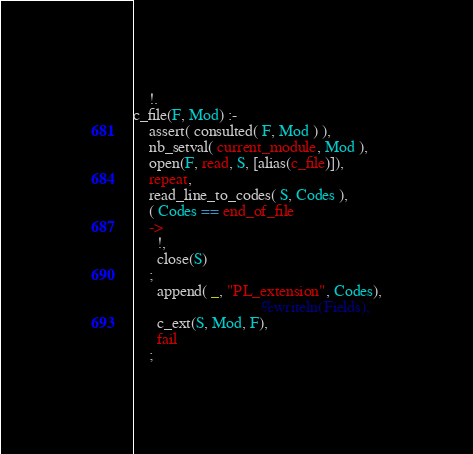Convert code to text. <code><loc_0><loc_0><loc_500><loc_500><_Prolog_>	!.
c_file(F, Mod) :-
	assert( consulted( F, Mod ) ),
	nb_setval( current_module, Mod ),
	open(F, read, S, [alias(c_file)]),
	repeat,
	read_line_to_codes( S, Codes ),
	( Codes == end_of_file
	->
	  !,
	  close(S)
	;
	  append( _, "PL_extension", Codes),
                                %writeln(Fields),
	  c_ext(S, Mod, F),
	  fail
	;</code> 